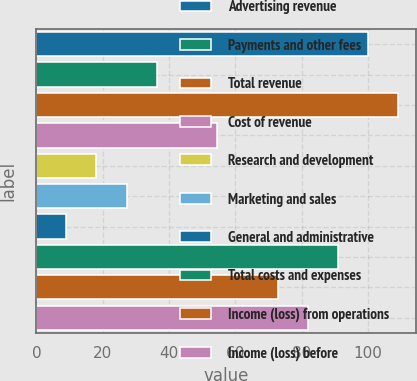<chart> <loc_0><loc_0><loc_500><loc_500><bar_chart><fcel>Advertising revenue<fcel>Payments and other fees<fcel>Total revenue<fcel>Cost of revenue<fcel>Research and development<fcel>Marketing and sales<fcel>General and administrative<fcel>Total costs and expenses<fcel>Income (loss) from operations<fcel>Income (loss) before<nl><fcel>100<fcel>36.3<fcel>109.1<fcel>54.5<fcel>18.1<fcel>27.2<fcel>9<fcel>90.9<fcel>72.7<fcel>81.8<nl></chart> 